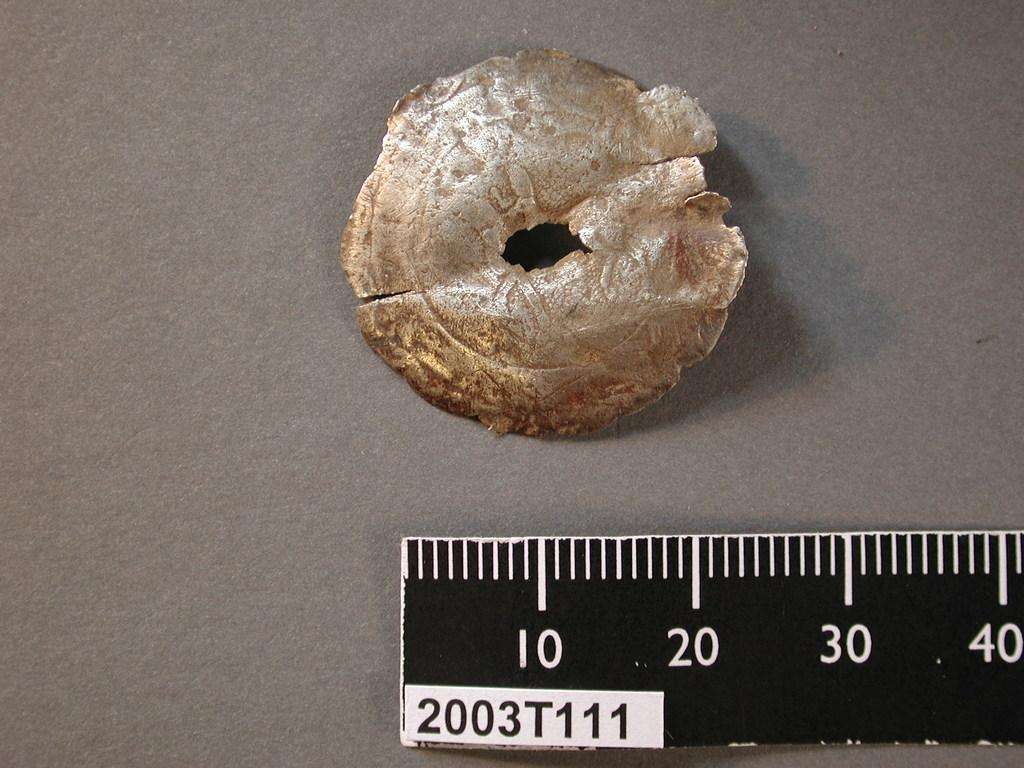<image>
Provide a brief description of the given image. A piece of goldish cement in the shape of a cirlce with a small hole inside of the circle with a ruler underneath with the a label 2003T111. 